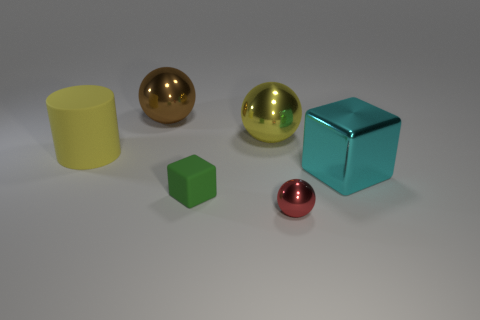Subtract all large yellow balls. How many balls are left? 2 Subtract all yellow balls. How many balls are left? 2 Add 4 tiny green matte cubes. How many objects exist? 10 Subtract all cubes. How many objects are left? 4 Subtract all yellow spheres. Subtract all green blocks. How many spheres are left? 2 Subtract all yellow blocks. How many purple cylinders are left? 0 Subtract all tiny blue blocks. Subtract all yellow objects. How many objects are left? 4 Add 4 large brown spheres. How many large brown spheres are left? 5 Add 6 tiny blue shiny cubes. How many tiny blue shiny cubes exist? 6 Subtract 0 purple cylinders. How many objects are left? 6 